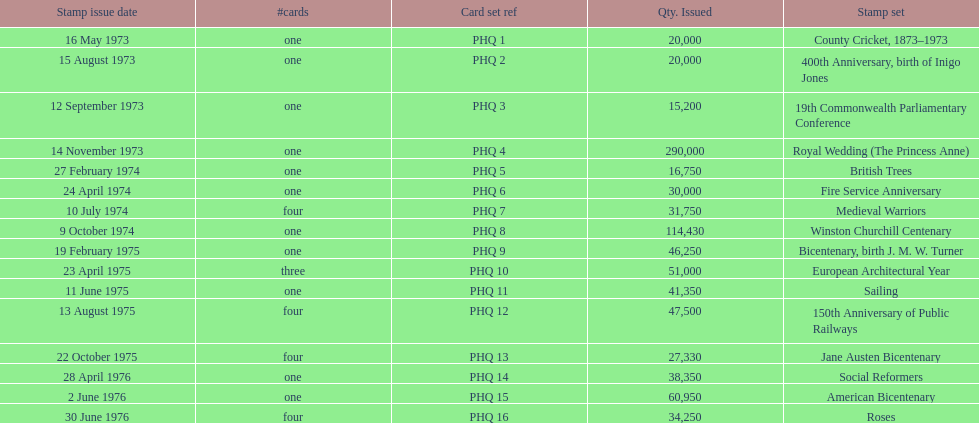List each bicentenary stamp set Bicentenary, birth J. M. W. Turner, Jane Austen Bicentenary, American Bicentenary. 